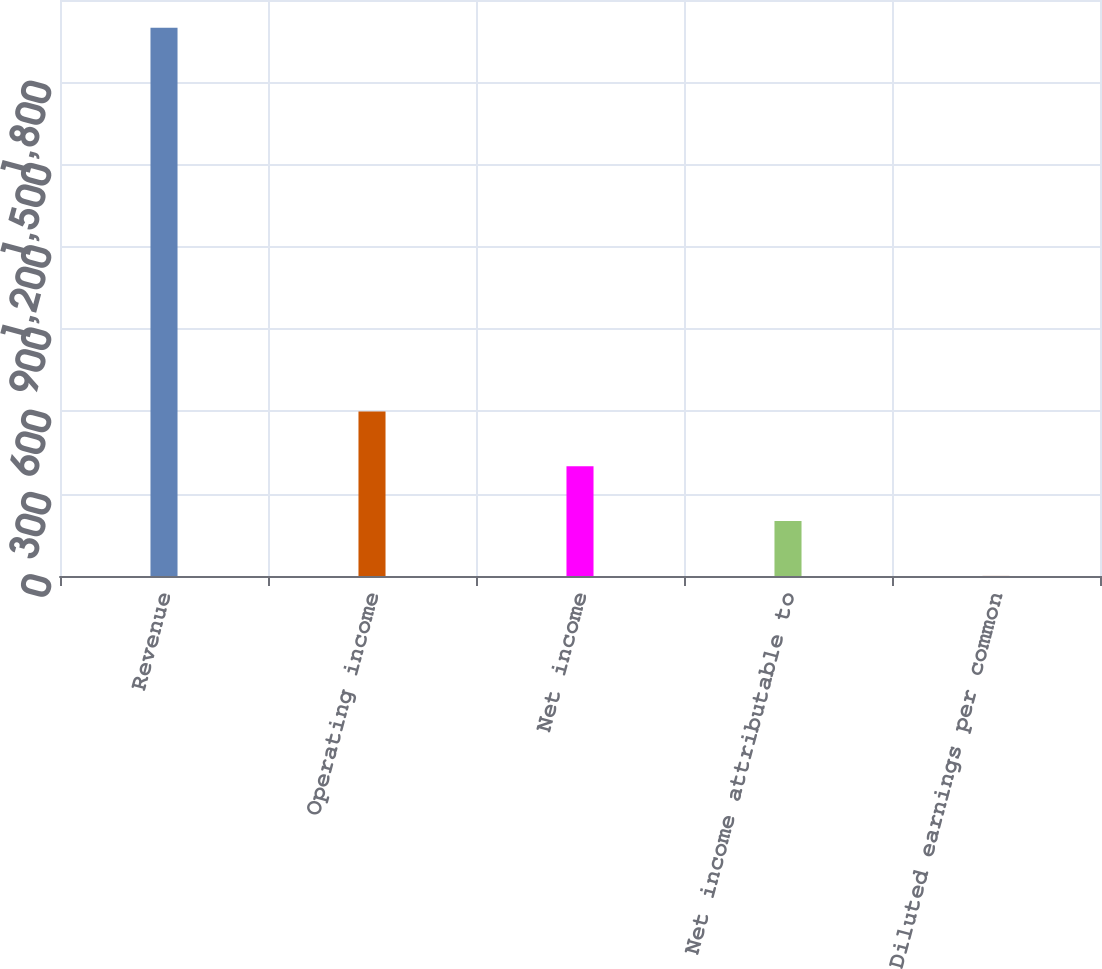<chart> <loc_0><loc_0><loc_500><loc_500><bar_chart><fcel>Revenue<fcel>Operating income<fcel>Net income<fcel>Net income attributable to<fcel>Diluted earnings per common<nl><fcel>1998.6<fcel>599.83<fcel>400<fcel>200.17<fcel>0.34<nl></chart> 